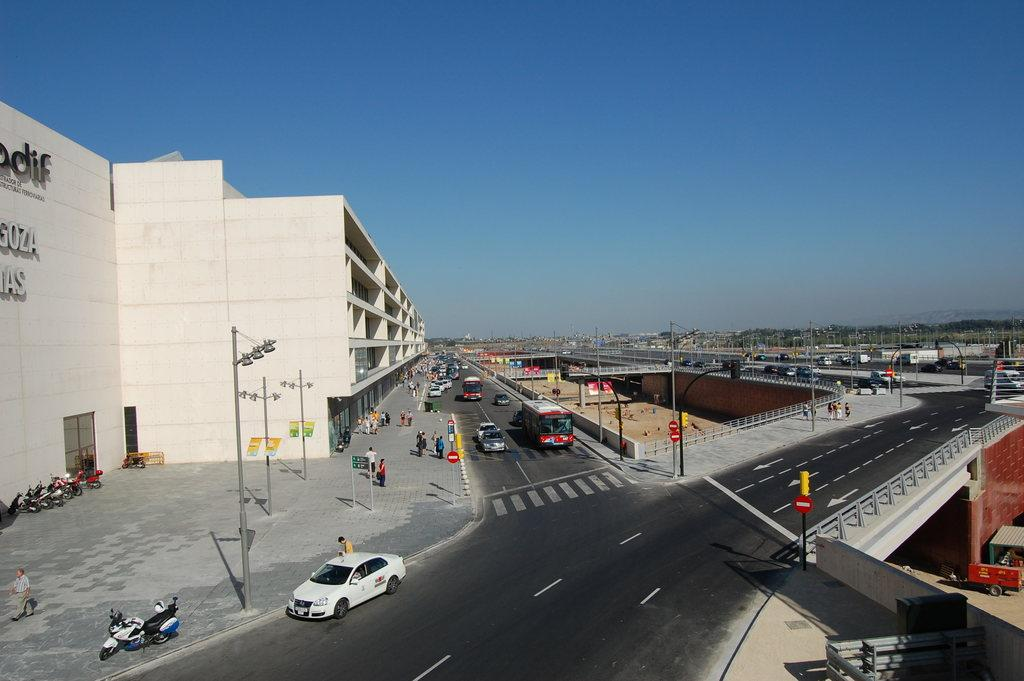What type of transportation infrastructure is visible in the image? There are roads in the image. What structures can be seen alongside the roads? There are poles in the image. What type of vehicle is present in the image? There is a car in the image. What other mode of transportation can be seen in the image? There are bikes in the image. Are there any people visible in the image? Yes, there are people in the image. What type of building can be seen in the image? There is a building in the image. What part of the natural environment is visible in the image? The sky is visible in the image. What type of disease is being treated in the image? There is no indication of any disease or medical treatment in the image. What flavor of pie is being served in the image? There is no pie present in the image. 